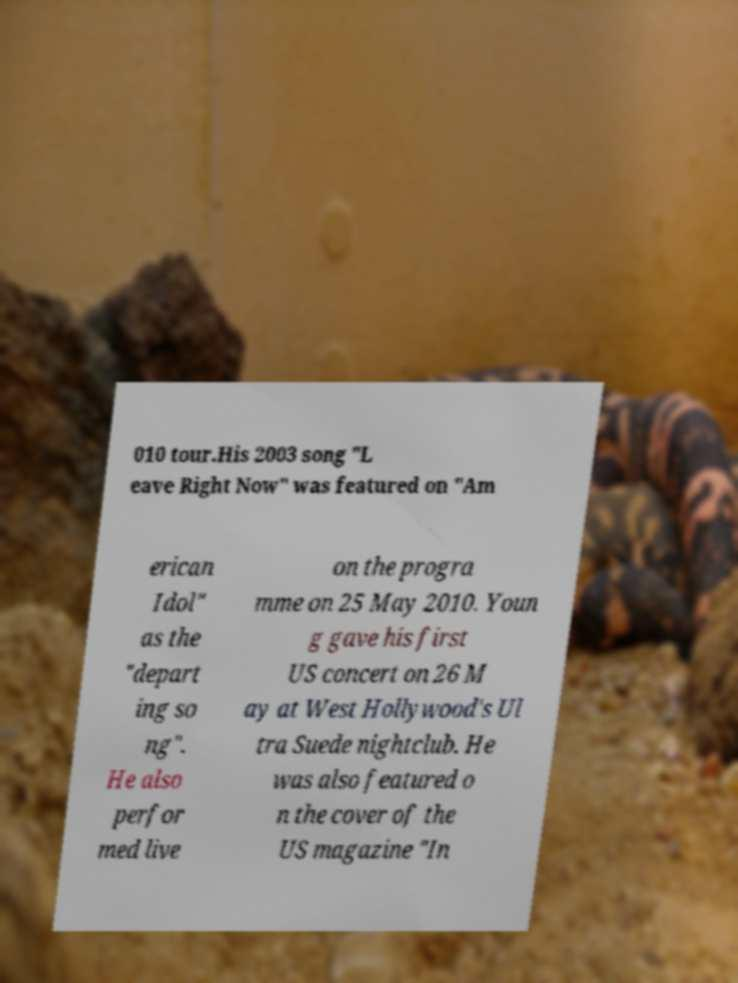I need the written content from this picture converted into text. Can you do that? 010 tour.His 2003 song "L eave Right Now" was featured on "Am erican Idol" as the "depart ing so ng". He also perfor med live on the progra mme on 25 May 2010. Youn g gave his first US concert on 26 M ay at West Hollywood's Ul tra Suede nightclub. He was also featured o n the cover of the US magazine "In 